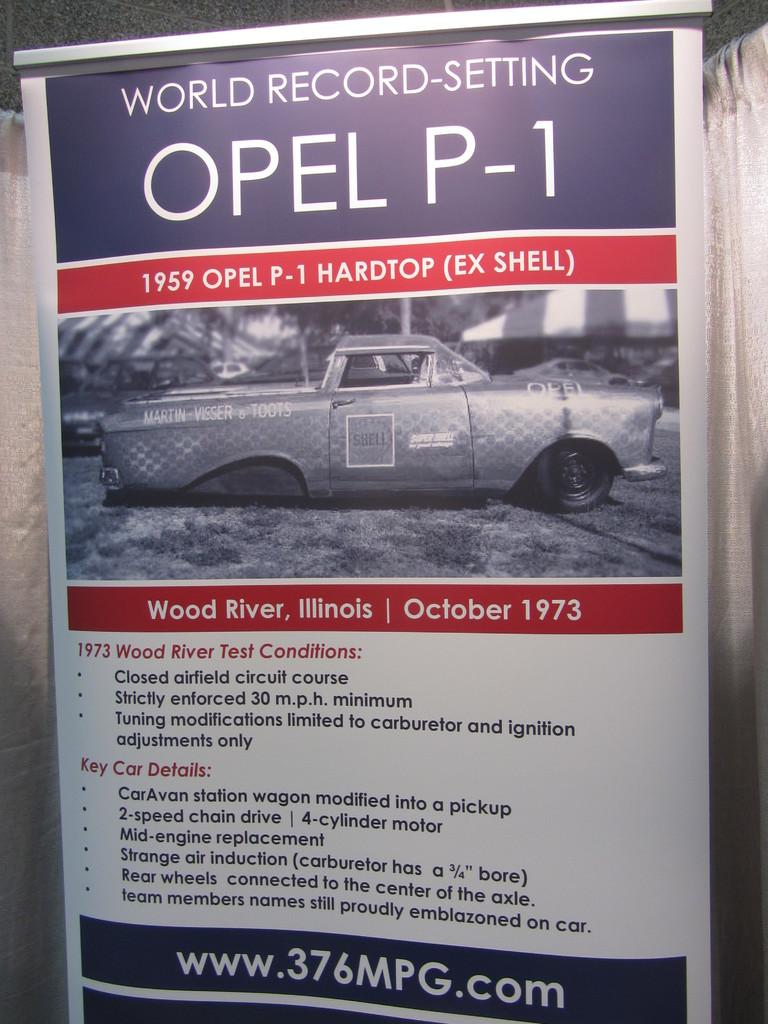What is present in the image that contains visual information? There is a poster in the image that contains images. What else can be found on the poster besides images? The poster contains text as well. How many cows are depicted on the poster in the image? There is no information about cows on the poster in the image; it contains images and text, but no mention of cows. 